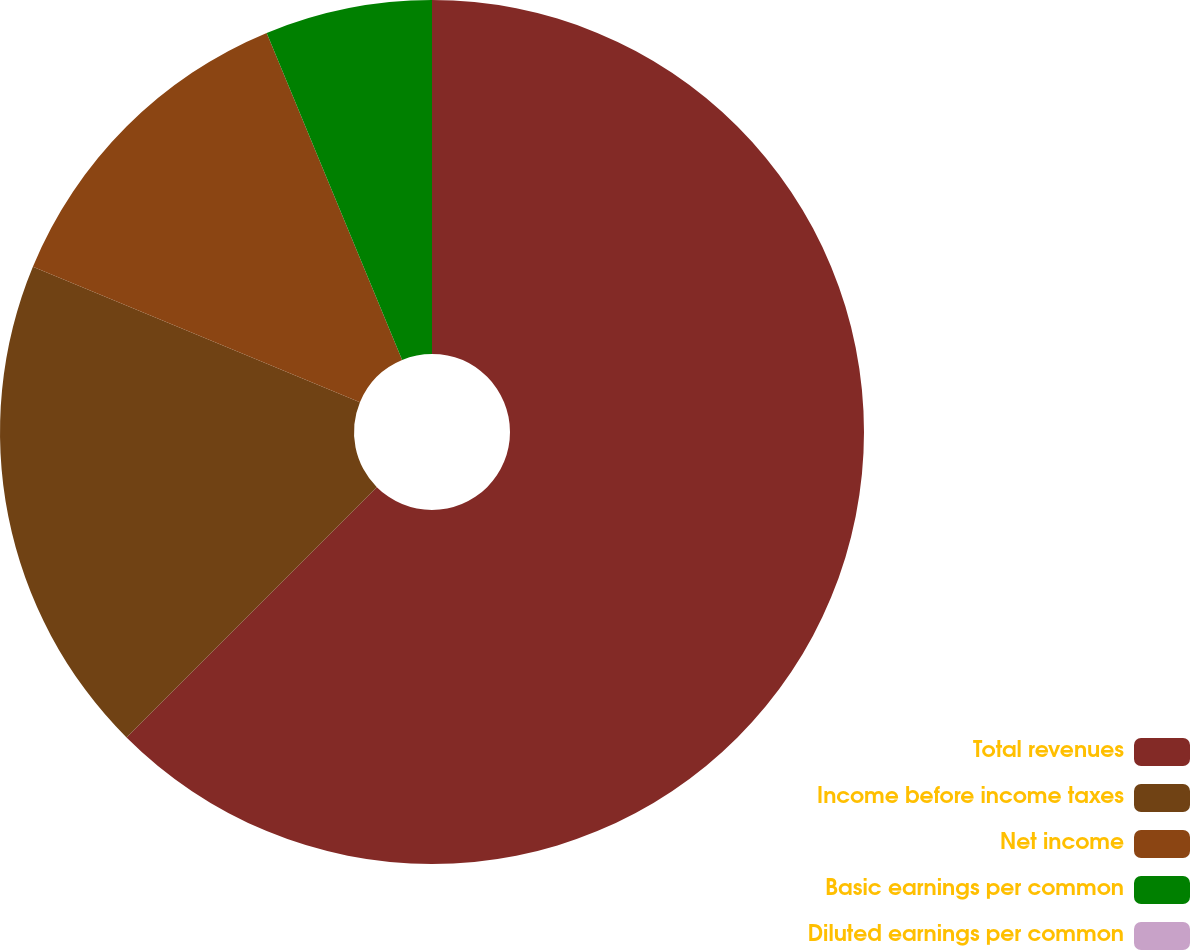<chart> <loc_0><loc_0><loc_500><loc_500><pie_chart><fcel>Total revenues<fcel>Income before income taxes<fcel>Net income<fcel>Basic earnings per common<fcel>Diluted earnings per common<nl><fcel>62.5%<fcel>18.75%<fcel>12.5%<fcel>6.25%<fcel>0.0%<nl></chart> 